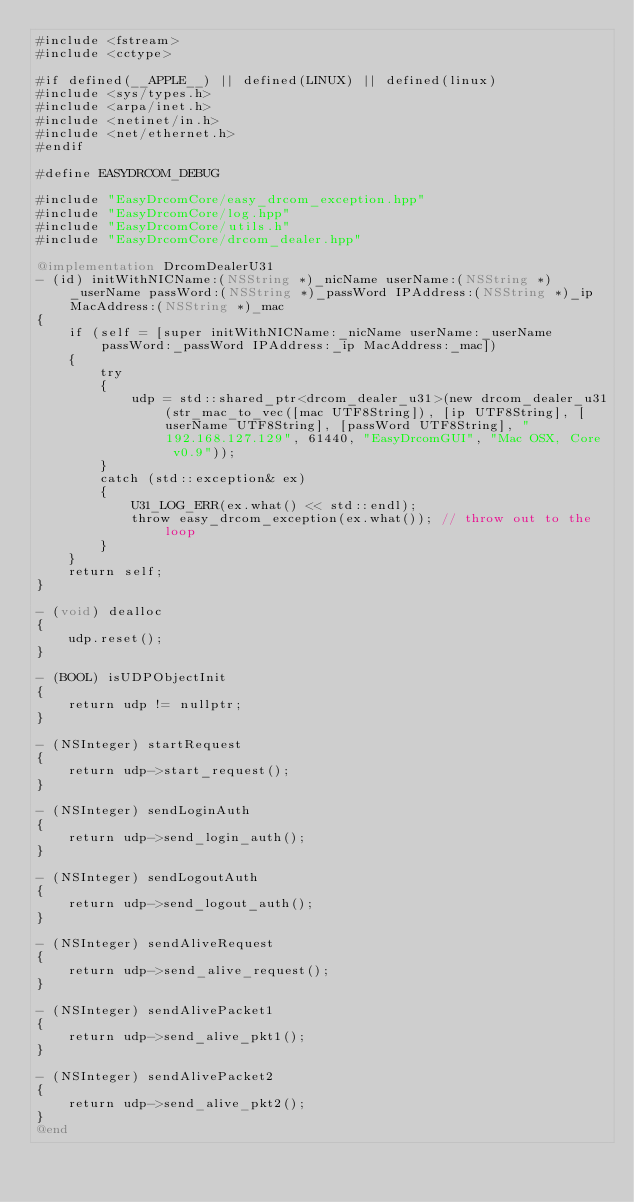Convert code to text. <code><loc_0><loc_0><loc_500><loc_500><_ObjectiveC_>#include <fstream>
#include <cctype>

#if defined(__APPLE__) || defined(LINUX) || defined(linux)
#include <sys/types.h>
#include <arpa/inet.h>
#include <netinet/in.h>
#include <net/ethernet.h>
#endif

#define EASYDRCOM_DEBUG

#include "EasyDrcomCore/easy_drcom_exception.hpp"
#include "EasyDrcomCore/log.hpp"
#include "EasyDrcomCore/utils.h"
#include "EasyDrcomCore/drcom_dealer.hpp"

@implementation DrcomDealerU31
- (id) initWithNICName:(NSString *)_nicName userName:(NSString *)_userName passWord:(NSString *)_passWord IPAddress:(NSString *)_ip MacAddress:(NSString *)_mac
{
    if (self = [super initWithNICName:_nicName userName:_userName passWord:_passWord IPAddress:_ip MacAddress:_mac])
    {
        try
        {
            udp = std::shared_ptr<drcom_dealer_u31>(new drcom_dealer_u31(str_mac_to_vec([mac UTF8String]), [ip UTF8String], [userName UTF8String], [passWord UTF8String], "192.168.127.129", 61440, "EasyDrcomGUI", "Mac OSX, Core v0.9"));
        }
        catch (std::exception& ex)
        {
            U31_LOG_ERR(ex.what() << std::endl);
            throw easy_drcom_exception(ex.what()); // throw out to the loop
        }
    }
    return self;
}

- (void) dealloc
{
    udp.reset();
}

- (BOOL) isUDPObjectInit
{
    return udp != nullptr;
}

- (NSInteger) startRequest
{
    return udp->start_request();
}

- (NSInteger) sendLoginAuth
{
    return udp->send_login_auth();
}

- (NSInteger) sendLogoutAuth
{
    return udp->send_logout_auth();
}

- (NSInteger) sendAliveRequest
{
    return udp->send_alive_request();
}

- (NSInteger) sendAlivePacket1
{
    return udp->send_alive_pkt1();
}

- (NSInteger) sendAlivePacket2
{
    return udp->send_alive_pkt2();
}
@end
</code> 